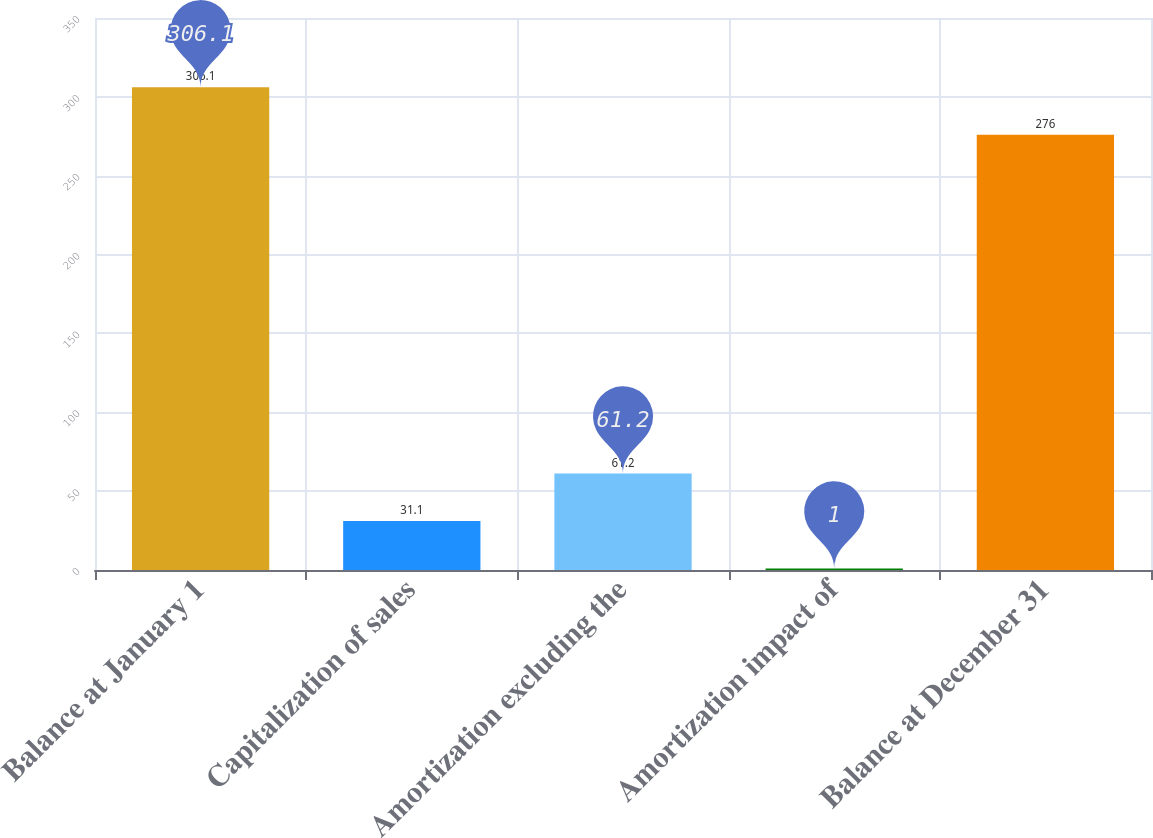<chart> <loc_0><loc_0><loc_500><loc_500><bar_chart><fcel>Balance at January 1<fcel>Capitalization of sales<fcel>Amortization excluding the<fcel>Amortization impact of<fcel>Balance at December 31<nl><fcel>306.1<fcel>31.1<fcel>61.2<fcel>1<fcel>276<nl></chart> 